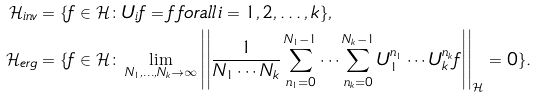<formula> <loc_0><loc_0><loc_500><loc_500>\mathcal { H } _ { i n v } & = \{ f \in \mathcal { H } \colon U _ { i } f = f \, f o r a l l \, i = 1 , 2 , \dots , k \} , \\ \mathcal { H } _ { e r g } & = \{ f \in \mathcal { H } \colon \lim _ { N _ { 1 } , \dots , N _ { k } \rightarrow \infty } \left | \left | \frac { 1 } { N _ { 1 } \cdots N _ { k } } \sum _ { n _ { 1 } = 0 } ^ { N _ { 1 } - 1 } \cdots \sum _ { n _ { k } = 0 } ^ { N _ { k } - 1 } U _ { 1 } ^ { n _ { 1 } } \cdots U _ { k } ^ { n _ { k } } f \right | \right | _ { \mathcal { H } } = 0 \} .</formula> 